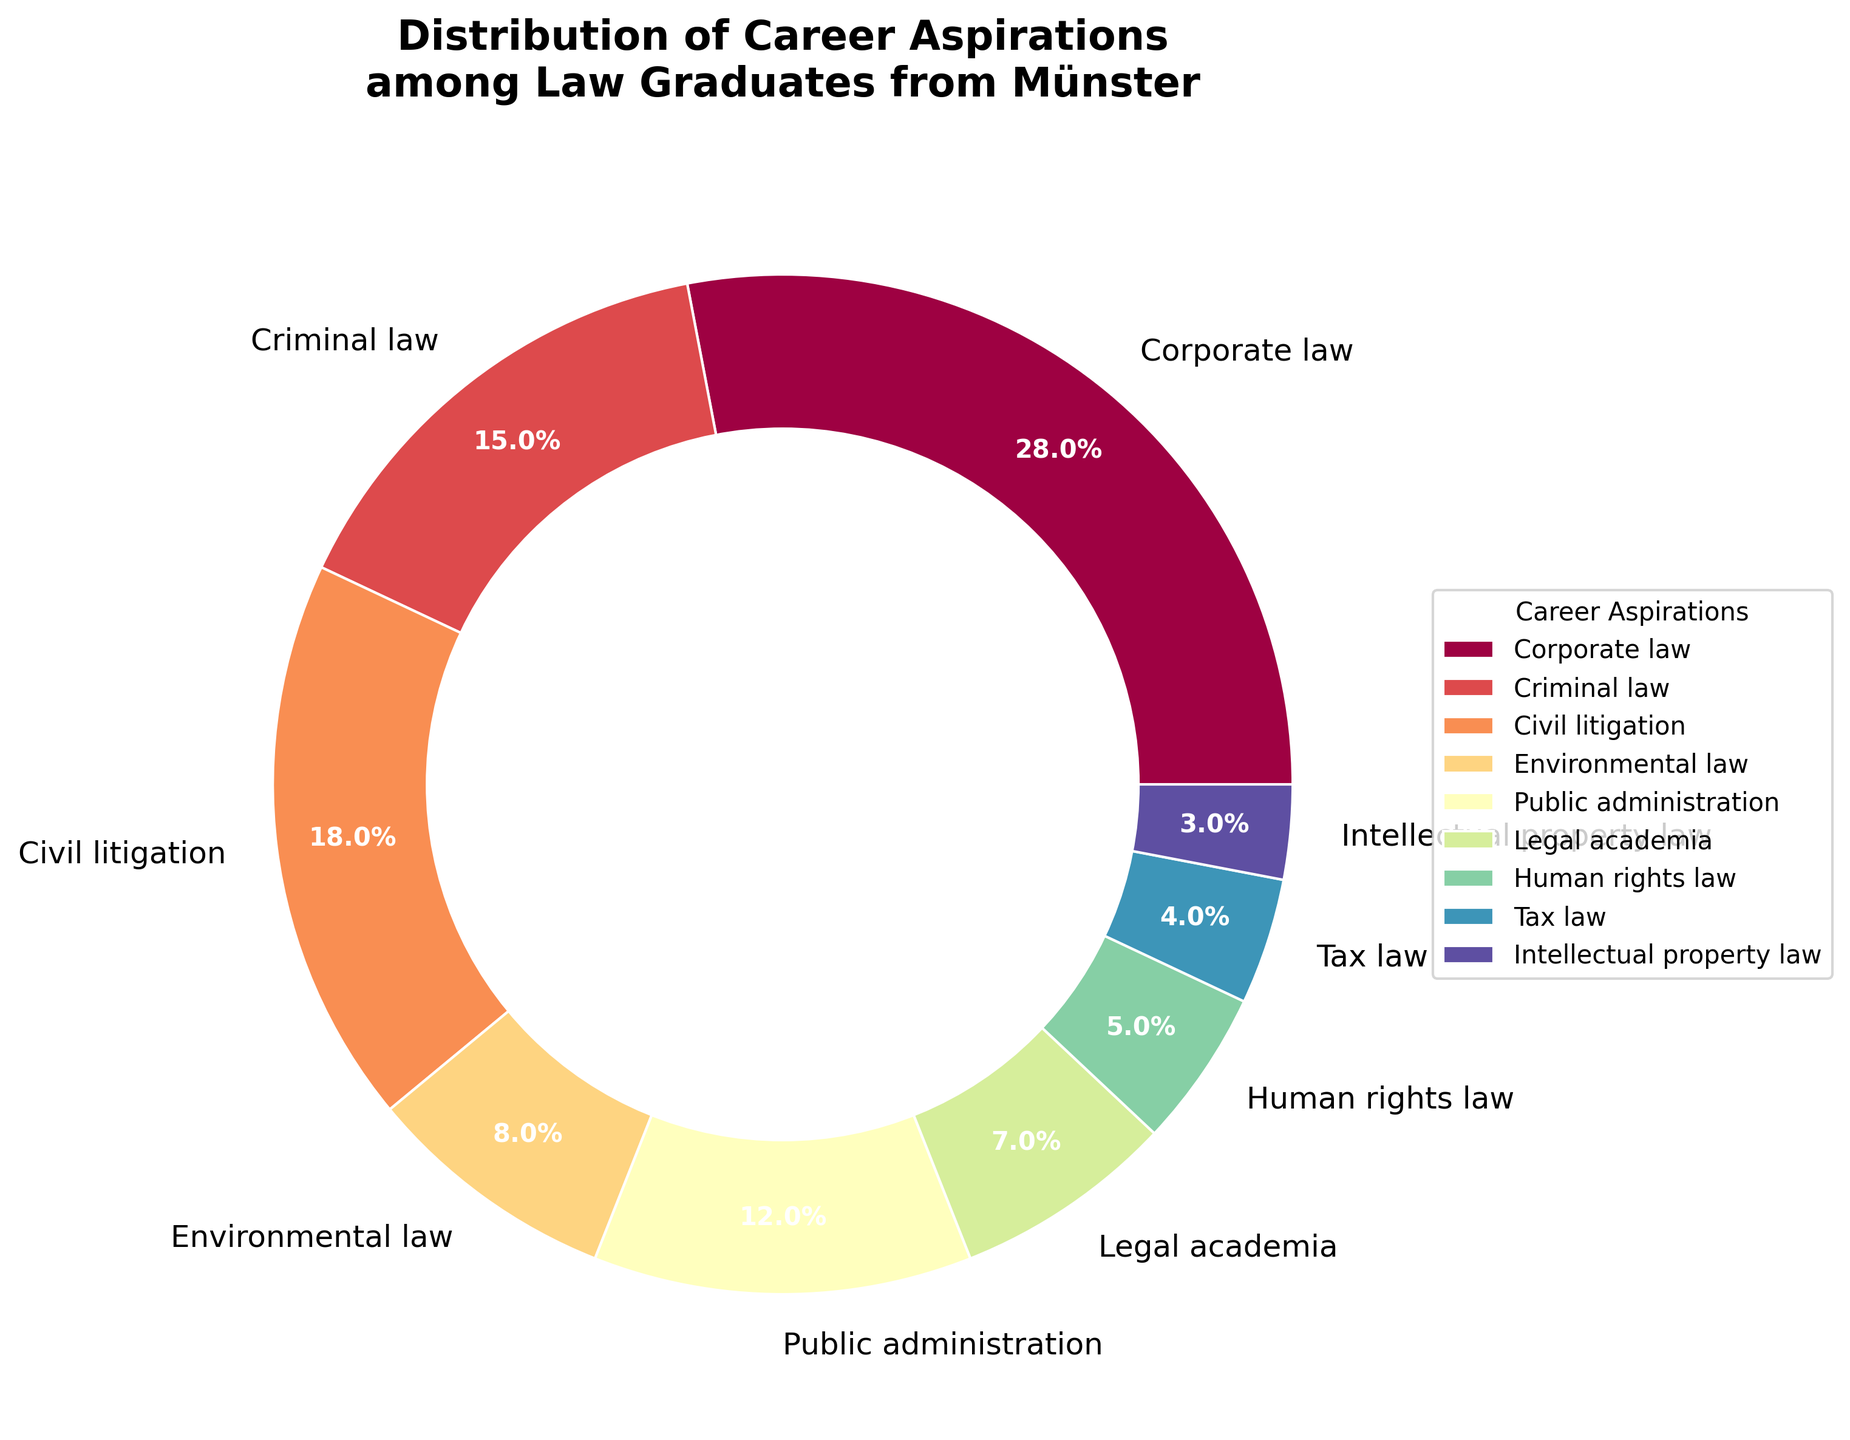What percentage of law graduates aspire to work in corporate law? Identify the section labeled "Corporate law" and note the percentage displayed within or next to it.
Answer: 28% Which career aspiration has the smallest percentage among law graduates from Münster? Look for the section with the smallest wedge or lowest percentage label.
Answer: Intellectual property law What is the combined percentage of graduates interested in environmental law and public administration? Locate the percentages for environmental law and public administration and add them together. Environmental law is 8% and public administration is 12%. Thus, 8% + 12% = 20%.
Answer: 20% How many career aspirations have a percentage greater than 10%? Identify the sections with percentages greater than 10%. These are corporate law (28%), civil litigation (18%), and criminal law (15%), public administration (12%). Count them.
Answer: 4 Compare the interest in criminal law and human rights law among graduates. Which one is more popular? Note the percentages for criminal law (15%) and human rights law (5%). Criminal law has a higher percentage.
Answer: Criminal law What is the difference in percentage points between corporate law and civil litigation aspirations? Subtract the percentage of civil litigation (18%) from the percentage of corporate law (28%). Thus, 28% - 18% = 10%.
Answer: 10% What is the total percentage of graduates aspiring to work in fields other than criminal law and civil litigation? Subtract the combined percentage of criminal law (15%) and civil litigation (18%) from 100%. Thus, 100% - (15% + 18%) = 67%.
Answer: 67% Identify the segment with the color at the top of the pie chart. What career does it represent, and what percentage does it hold? Observe the colored segment at the top and match it to the corresponding label. Note the career aspiration and its percentage. (Assuming the top segment is environmental law based on the arranged order)
Answer: Environmental law, 8% What is the combined percentage of law graduates aspiring to work in tax law and intellectual property law? Add the percentages of tax law (4%) and intellectual property law (3%). Thus, 4% + 3% = 7%.
Answer: 7% Do more graduates aspire to work in legal academia or human rights law? Compare the percentages of legal academia (7%) and human rights law (5%). Legal academia has a higher percentage.
Answer: Legal academia 